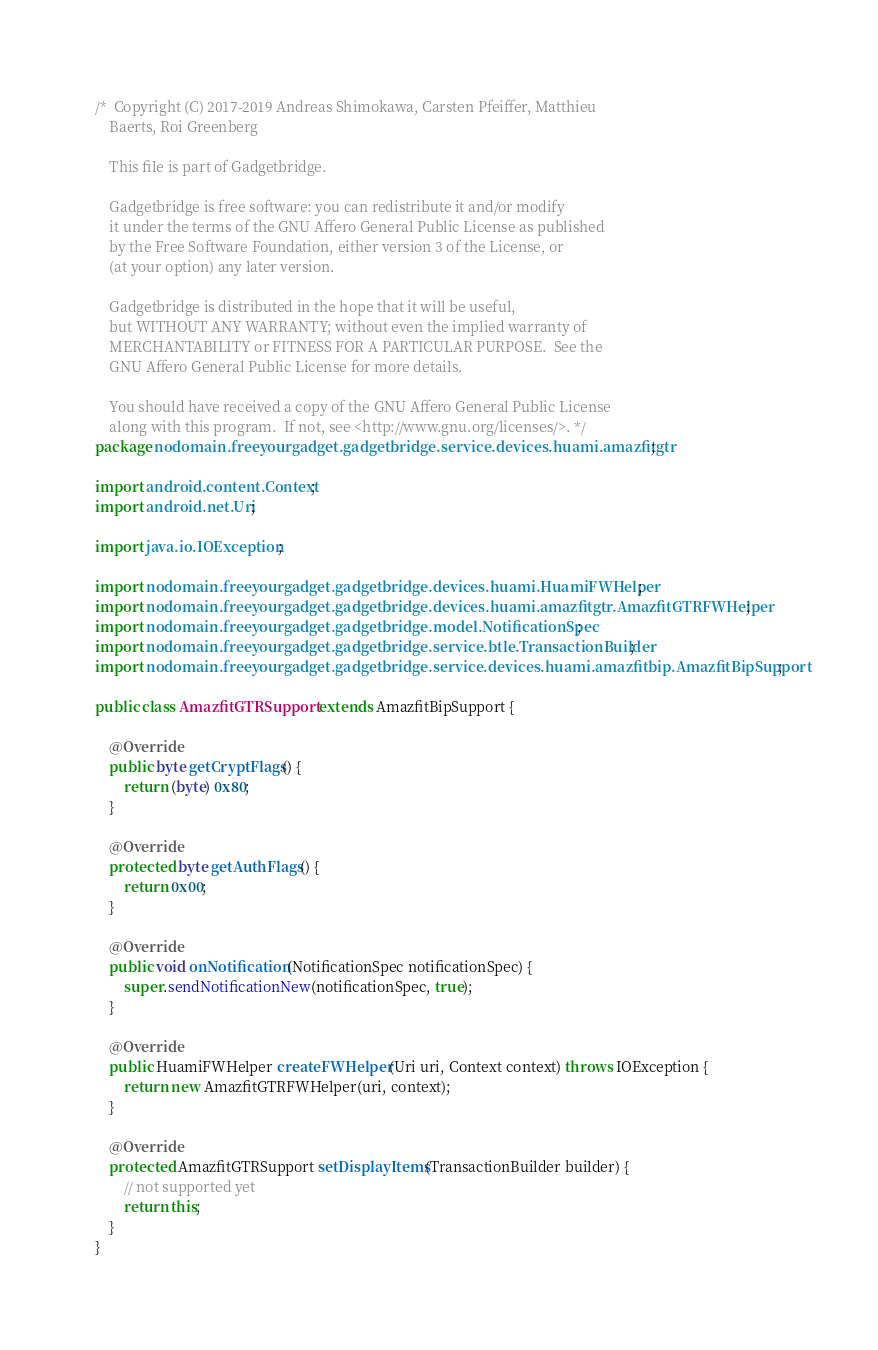Convert code to text. <code><loc_0><loc_0><loc_500><loc_500><_Java_>/*  Copyright (C) 2017-2019 Andreas Shimokawa, Carsten Pfeiffer, Matthieu
    Baerts, Roi Greenberg

    This file is part of Gadgetbridge.

    Gadgetbridge is free software: you can redistribute it and/or modify
    it under the terms of the GNU Affero General Public License as published
    by the Free Software Foundation, either version 3 of the License, or
    (at your option) any later version.

    Gadgetbridge is distributed in the hope that it will be useful,
    but WITHOUT ANY WARRANTY; without even the implied warranty of
    MERCHANTABILITY or FITNESS FOR A PARTICULAR PURPOSE.  See the
    GNU Affero General Public License for more details.

    You should have received a copy of the GNU Affero General Public License
    along with this program.  If not, see <http://www.gnu.org/licenses/>. */
package nodomain.freeyourgadget.gadgetbridge.service.devices.huami.amazfitgtr;

import android.content.Context;
import android.net.Uri;

import java.io.IOException;

import nodomain.freeyourgadget.gadgetbridge.devices.huami.HuamiFWHelper;
import nodomain.freeyourgadget.gadgetbridge.devices.huami.amazfitgtr.AmazfitGTRFWHelper;
import nodomain.freeyourgadget.gadgetbridge.model.NotificationSpec;
import nodomain.freeyourgadget.gadgetbridge.service.btle.TransactionBuilder;
import nodomain.freeyourgadget.gadgetbridge.service.devices.huami.amazfitbip.AmazfitBipSupport;

public class AmazfitGTRSupport extends AmazfitBipSupport {

    @Override
    public byte getCryptFlags() {
        return (byte) 0x80;
    }
    
    @Override
    protected byte getAuthFlags() {
        return 0x00;
    }

    @Override
    public void onNotification(NotificationSpec notificationSpec) {
        super.sendNotificationNew(notificationSpec, true);
    }

    @Override
    public HuamiFWHelper createFWHelper(Uri uri, Context context) throws IOException {
        return new AmazfitGTRFWHelper(uri, context);
    }

    @Override
    protected AmazfitGTRSupport setDisplayItems(TransactionBuilder builder) {
        // not supported yet
        return this;
    }
}
</code> 